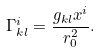Convert formula to latex. <formula><loc_0><loc_0><loc_500><loc_500>\Gamma _ { k l } ^ { i } = \frac { g _ { k l } x ^ { i } } { r _ { 0 } ^ { 2 } } .</formula> 